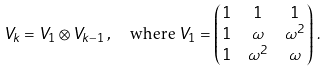<formula> <loc_0><loc_0><loc_500><loc_500>V _ { k } & = V _ { 1 } \otimes V _ { k - 1 } \, , \quad \text {where\ } V _ { 1 } = \begin{pmatrix} 1 & 1 & 1 \\ 1 & \omega & \omega ^ { 2 } \\ 1 & \omega ^ { 2 } & \omega \end{pmatrix} \, .</formula> 